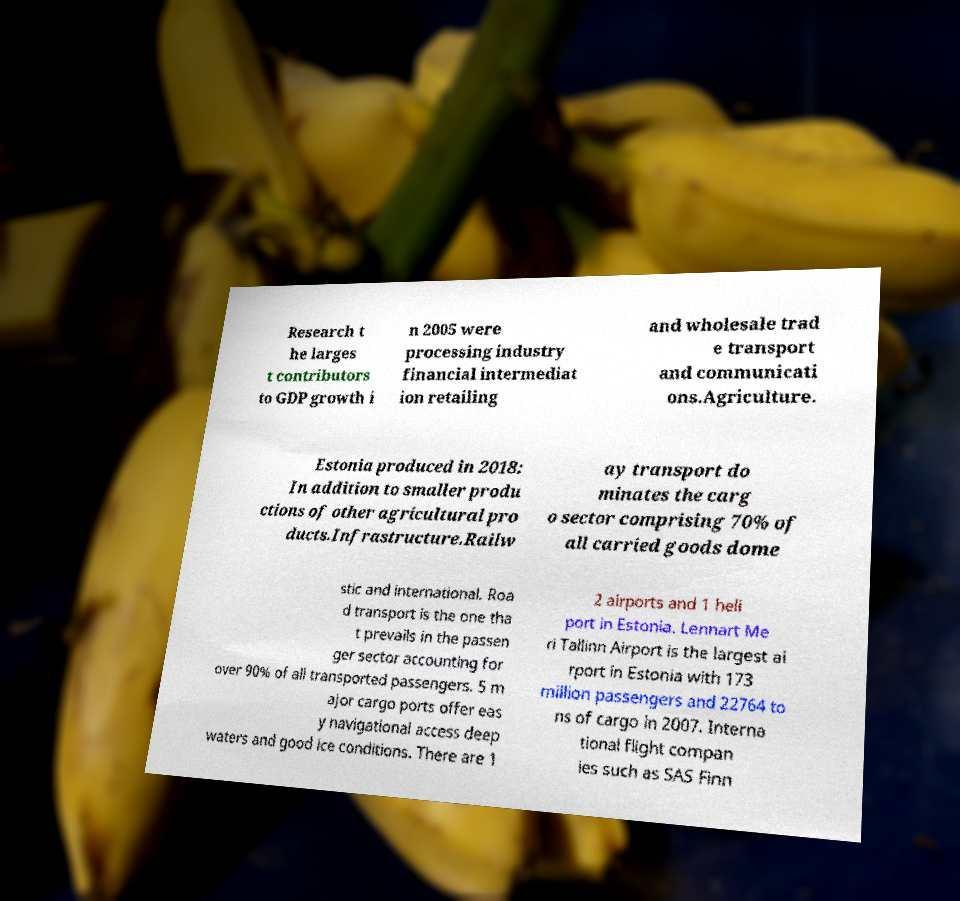Can you read and provide the text displayed in the image?This photo seems to have some interesting text. Can you extract and type it out for me? Research t he larges t contributors to GDP growth i n 2005 were processing industry financial intermediat ion retailing and wholesale trad e transport and communicati ons.Agriculture. Estonia produced in 2018: In addition to smaller produ ctions of other agricultural pro ducts.Infrastructure.Railw ay transport do minates the carg o sector comprising 70% of all carried goods dome stic and international. Roa d transport is the one tha t prevails in the passen ger sector accounting for over 90% of all transported passengers. 5 m ajor cargo ports offer eas y navigational access deep waters and good ice conditions. There are 1 2 airports and 1 heli port in Estonia. Lennart Me ri Tallinn Airport is the largest ai rport in Estonia with 173 million passengers and 22764 to ns of cargo in 2007. Interna tional flight compan ies such as SAS Finn 